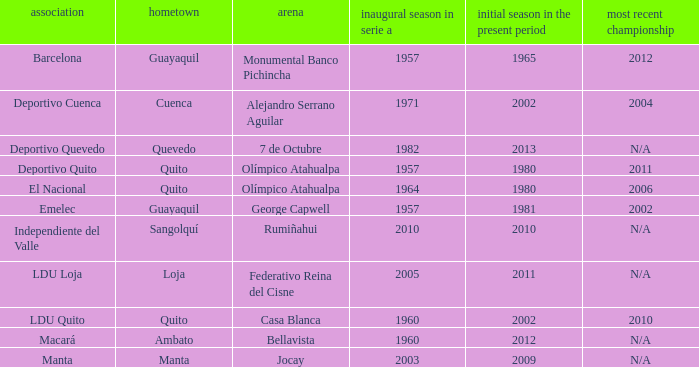Name the first season in the series for 2006 1964.0. 